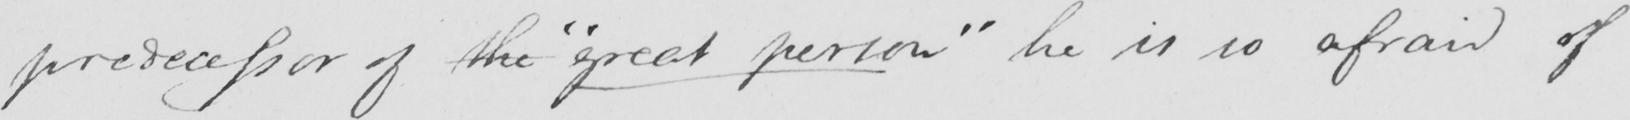Please provide the text content of this handwritten line. predecessor of the  " great person "  he is so afraid of 